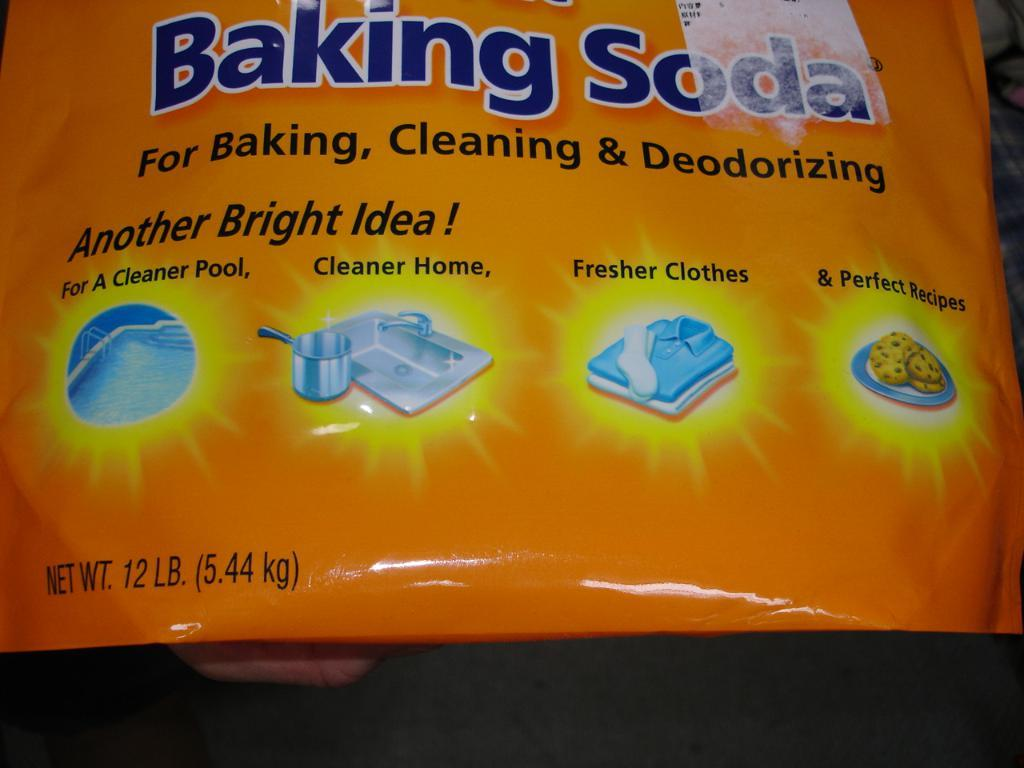What is depicted on the cover in the image? The cover has a bowl, a sink, and a tap on it. What else is on the cover? There is some text on the cover. What other items can be seen in the image? There are clothes, a plate with food items, and a swimming pool in the image. How many chairs are present in the image? There are no chairs visible in the image. What type of beast can be seen interacting with the swimming pool in the image? There is no beast present in the image; only the swimming pool and other items mentioned in the facts are visible. 